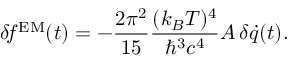<formula> <loc_0><loc_0><loc_500><loc_500>\delta \, f ^ { E M } ( t ) = - { \frac { 2 \pi ^ { 2 } } { 1 5 } } { \frac { ( k _ { B } T ) ^ { 4 } } { \hbar { ^ } { 3 } c ^ { 4 } } } A \, \delta \dot { q } ( t ) .</formula> 